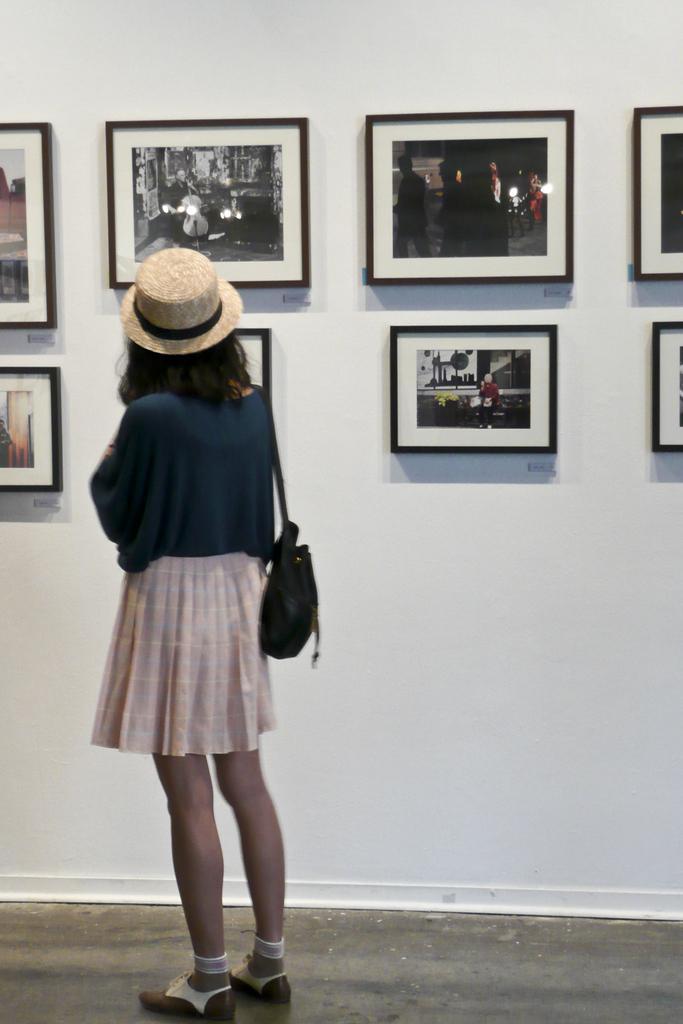Please provide a concise description of this image. On the left side there is a woman wearing a bag, cap on the head and standing on the floor facing towards the back side. In the background there are few photo frames attached to the wall. 